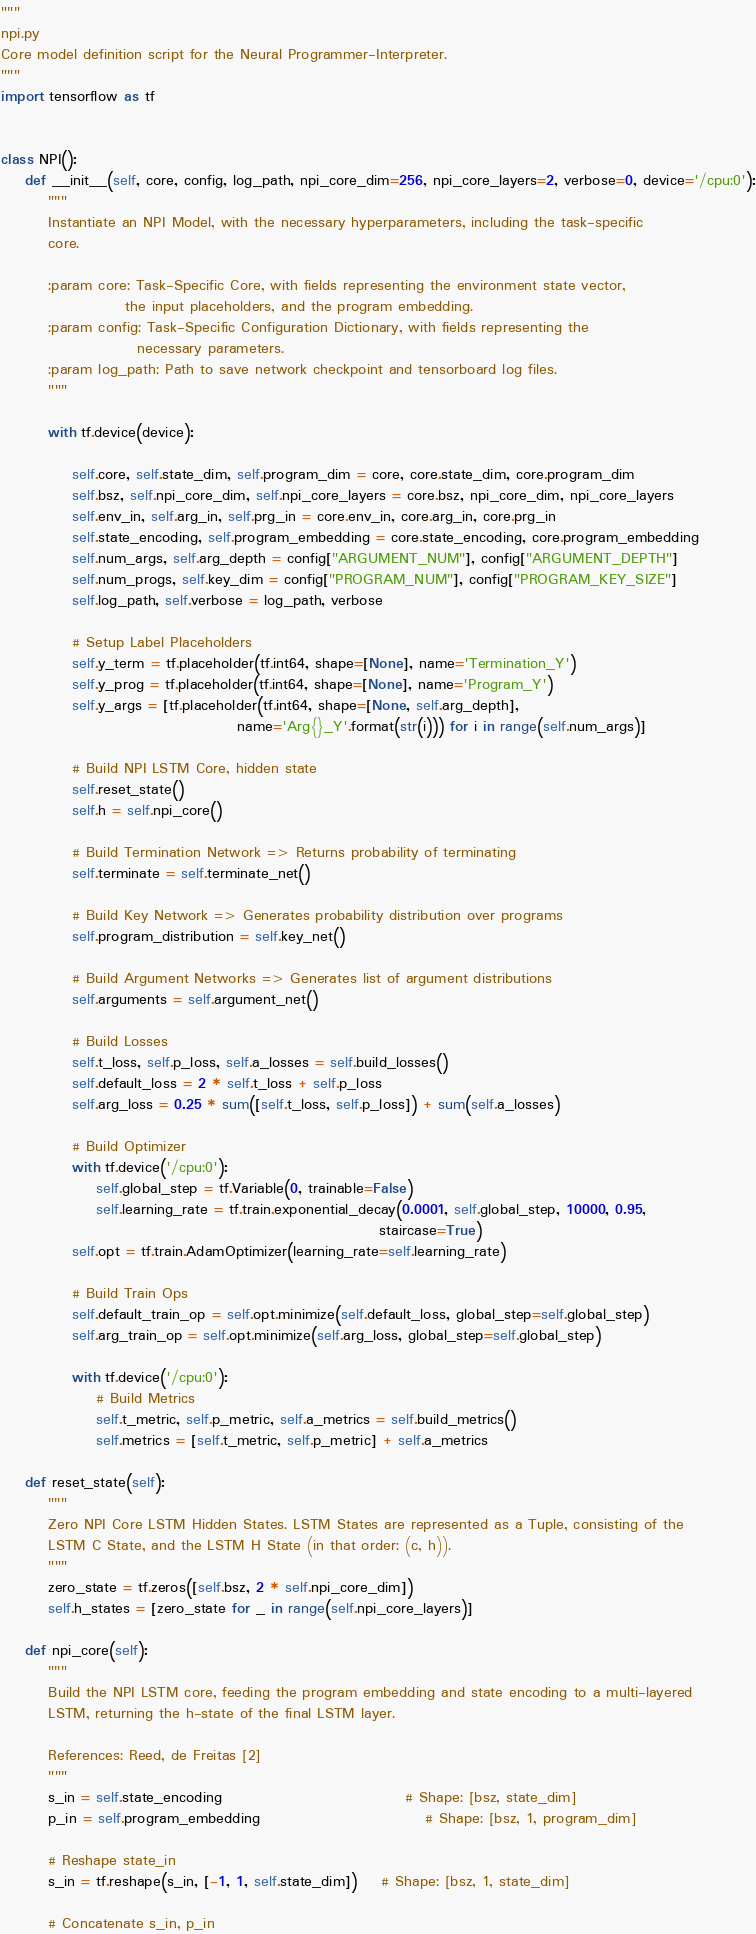<code> <loc_0><loc_0><loc_500><loc_500><_Python_>"""
npi.py
Core model definition script for the Neural Programmer-Interpreter.
"""
import tensorflow as tf


class NPI():
    def __init__(self, core, config, log_path, npi_core_dim=256, npi_core_layers=2, verbose=0, device='/cpu:0'):
        """
        Instantiate an NPI Model, with the necessary hyperparameters, including the task-specific
        core.

        :param core: Task-Specific Core, with fields representing the environment state vector,
                     the input placeholders, and the program embedding.
        :param config: Task-Specific Configuration Dictionary, with fields representing the
                       necessary parameters.
        :param log_path: Path to save network checkpoint and tensorboard log files.
        """

        with tf.device(device):

            self.core, self.state_dim, self.program_dim = core, core.state_dim, core.program_dim
            self.bsz, self.npi_core_dim, self.npi_core_layers = core.bsz, npi_core_dim, npi_core_layers
            self.env_in, self.arg_in, self.prg_in = core.env_in, core.arg_in, core.prg_in
            self.state_encoding, self.program_embedding = core.state_encoding, core.program_embedding
            self.num_args, self.arg_depth = config["ARGUMENT_NUM"], config["ARGUMENT_DEPTH"]
            self.num_progs, self.key_dim = config["PROGRAM_NUM"], config["PROGRAM_KEY_SIZE"]
            self.log_path, self.verbose = log_path, verbose

            # Setup Label Placeholders
            self.y_term = tf.placeholder(tf.int64, shape=[None], name='Termination_Y')
            self.y_prog = tf.placeholder(tf.int64, shape=[None], name='Program_Y')
            self.y_args = [tf.placeholder(tf.int64, shape=[None, self.arg_depth],
                                        name='Arg{}_Y'.format(str(i))) for i in range(self.num_args)]

            # Build NPI LSTM Core, hidden state
            self.reset_state()
            self.h = self.npi_core()

            # Build Termination Network => Returns probability of terminating
            self.terminate = self.terminate_net()

            # Build Key Network => Generates probability distribution over programs
            self.program_distribution = self.key_net()

            # Build Argument Networks => Generates list of argument distributions
            self.arguments = self.argument_net()

            # Build Losses
            self.t_loss, self.p_loss, self.a_losses = self.build_losses()
            self.default_loss = 2 * self.t_loss + self.p_loss
            self.arg_loss = 0.25 * sum([self.t_loss, self.p_loss]) + sum(self.a_losses)

            # Build Optimizer
            with tf.device('/cpu:0'):
                self.global_step = tf.Variable(0, trainable=False)
                self.learning_rate = tf.train.exponential_decay(0.0001, self.global_step, 10000, 0.95,
                                                                staircase=True)
            self.opt = tf.train.AdamOptimizer(learning_rate=self.learning_rate) 
                                               
            # Build Train Ops
            self.default_train_op = self.opt.minimize(self.default_loss, global_step=self.global_step)
            self.arg_train_op = self.opt.minimize(self.arg_loss, global_step=self.global_step)

            with tf.device('/cpu:0'):
                # Build Metrics
                self.t_metric, self.p_metric, self.a_metrics = self.build_metrics()
                self.metrics = [self.t_metric, self.p_metric] + self.a_metrics

    def reset_state(self):
        """
        Zero NPI Core LSTM Hidden States. LSTM States are represented as a Tuple, consisting of the
        LSTM C State, and the LSTM H State (in that order: (c, h)).
        """
        zero_state = tf.zeros([self.bsz, 2 * self.npi_core_dim])
        self.h_states = [zero_state for _ in range(self.npi_core_layers)]

    def npi_core(self):
        """
        Build the NPI LSTM core, feeding the program embedding and state encoding to a multi-layered
        LSTM, returning the h-state of the final LSTM layer.

        References: Reed, de Freitas [2]
        """
        s_in = self.state_encoding                               # Shape: [bsz, state_dim]
        p_in = self.program_embedding                            # Shape: [bsz, 1, program_dim]

        # Reshape state_in
        s_in = tf.reshape(s_in, [-1, 1, self.state_dim])    # Shape: [bsz, 1, state_dim]

        # Concatenate s_in, p_in</code> 